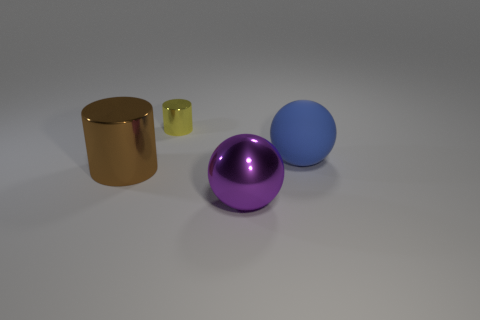There is a purple thing that is the same size as the matte sphere; what shape is it?
Ensure brevity in your answer.  Sphere. There is a big purple metal object that is in front of the sphere behind the large sphere in front of the brown metallic cylinder; what is its shape?
Give a very brief answer. Sphere. What number of large objects are there?
Provide a succinct answer. 3. There is a purple metallic object; are there any rubber objects in front of it?
Give a very brief answer. No. Do the thing to the left of the small yellow cylinder and the cylinder that is behind the rubber object have the same material?
Make the answer very short. Yes. Are there fewer blue spheres that are in front of the brown shiny thing than tiny blue shiny balls?
Keep it short and to the point. No. What is the color of the big rubber sphere to the right of the large brown metal cylinder?
Give a very brief answer. Blue. There is a big sphere that is behind the large object that is on the left side of the tiny shiny cylinder; what is its material?
Ensure brevity in your answer.  Rubber. Are there any brown metallic cylinders of the same size as the blue rubber thing?
Keep it short and to the point. Yes. How many things are either cylinders that are on the left side of the yellow thing or big metal things that are left of the large purple metal thing?
Offer a very short reply. 1. 